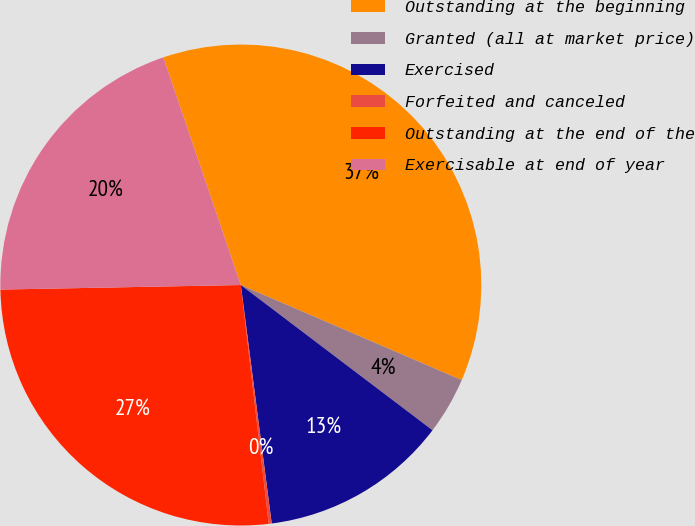Convert chart to OTSL. <chart><loc_0><loc_0><loc_500><loc_500><pie_chart><fcel>Outstanding at the beginning<fcel>Granted (all at market price)<fcel>Exercised<fcel>Forfeited and canceled<fcel>Outstanding at the end of the<fcel>Exercisable at end of year<nl><fcel>36.69%<fcel>3.85%<fcel>12.63%<fcel>0.2%<fcel>26.55%<fcel>20.08%<nl></chart> 